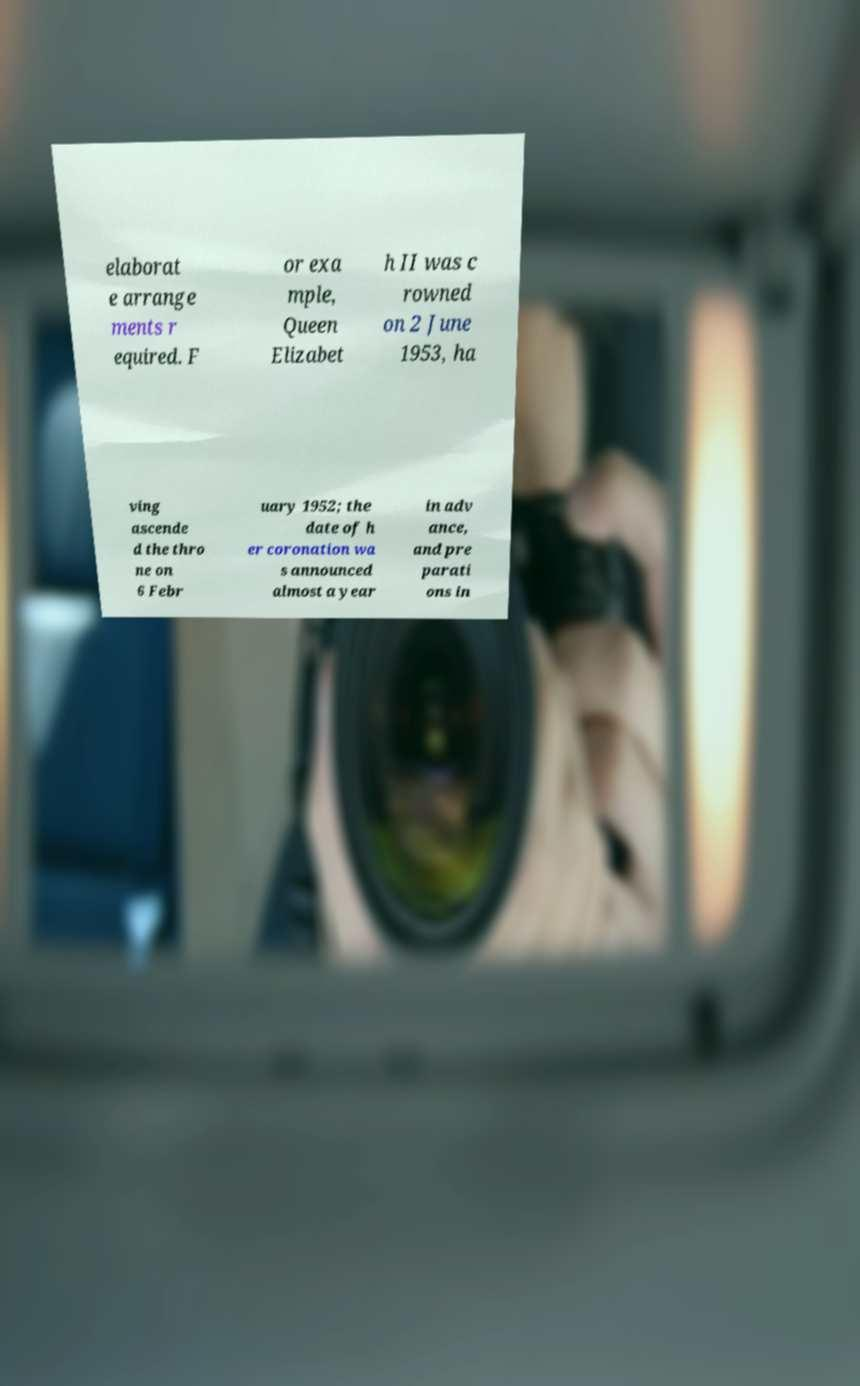Please read and relay the text visible in this image. What does it say? elaborat e arrange ments r equired. F or exa mple, Queen Elizabet h II was c rowned on 2 June 1953, ha ving ascende d the thro ne on 6 Febr uary 1952; the date of h er coronation wa s announced almost a year in adv ance, and pre parati ons in 